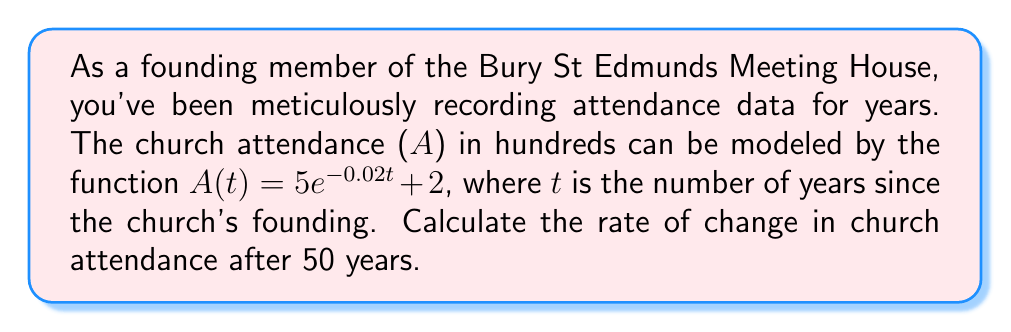Teach me how to tackle this problem. To find the rate of change in church attendance after 50 years, we need to calculate the derivative of the given function and evaluate it at t = 50.

Step 1: Find the derivative of $A(t)$.
$A(t) = 5e^{-0.02t} + 2$
$A'(t) = 5 \cdot (-0.02)e^{-0.02t} + 0$
$A'(t) = -0.1e^{-0.02t}$

Step 2: Evaluate $A'(t)$ at t = 50.
$A'(50) = -0.1e^{-0.02(50)}$
$A'(50) = -0.1e^{-1}$
$A'(50) \approx -0.0368$

Step 3: Interpret the result.
The rate of change is negative, indicating a decrease in attendance. The value is in hundreds per year, so we need to multiply by 100 to get the actual number of people.

$-0.0368 \cdot 100 \approx -3.68$ people per year
Answer: $-3.68$ people per year 